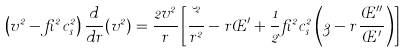<formula> <loc_0><loc_0><loc_500><loc_500>\left ( v ^ { 2 } - \beta ^ { 2 } c _ { s } ^ { 2 } \right ) \frac { d } { d r } ( v ^ { 2 } ) = \frac { 2 v ^ { 2 } } { r } \left [ \frac { \lambda ^ { 2 } } { r ^ { 2 } } - r \phi ^ { \prime } + \frac { 1 } { 2 } \beta ^ { 2 } c _ { s } ^ { 2 } \left ( 3 - r \frac { \phi ^ { \prime \prime } } { \phi ^ { \prime } } \right ) \right ]</formula> 